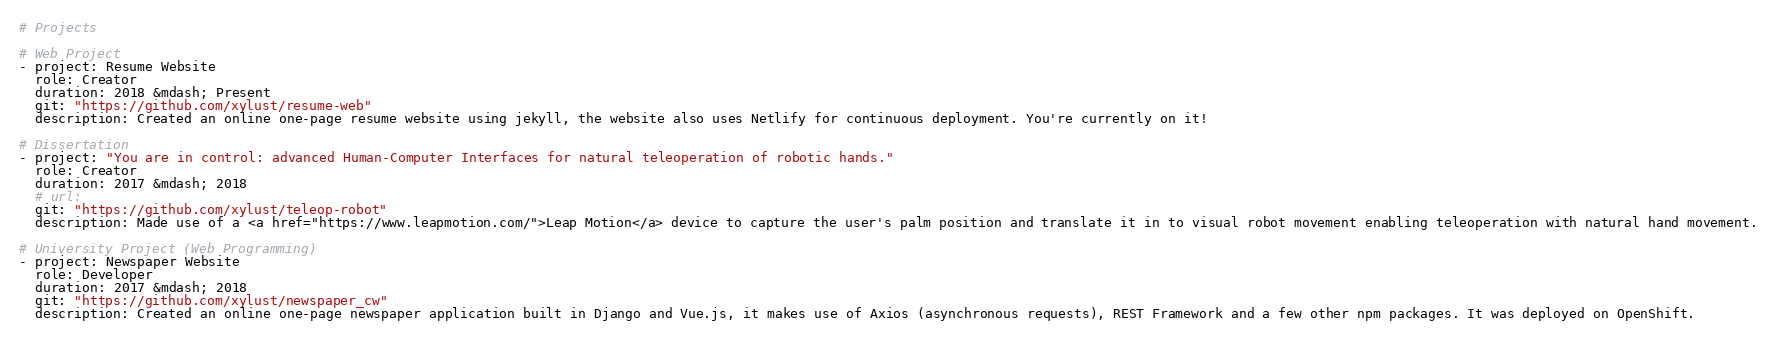<code> <loc_0><loc_0><loc_500><loc_500><_YAML_># Projects

# Web Project
- project: Resume Website
  role: Creator
  duration: 2018 &mdash; Present
  git: "https://github.com/xylust/resume-web"
  description: Created an online one-page resume website using jekyll, the website also uses Netlify for continuous deployment. You're currently on it!

# Dissertation
- project: "You are in control: advanced Human-Computer Interfaces for natural teleoperation of robotic hands."
  role: Creator
  duration: 2017 &mdash; 2018
  # url: 
  git: "https://github.com/xylust/teleop-robot"
  description: Made use of a <a href="https://www.leapmotion.com/">Leap Motion</a> device to capture the user's palm position and translate it in to visual robot movement enabling teleoperation with natural hand movement.

# University Project (Web Programming)
- project: Newspaper Website
  role: Developer
  duration: 2017 &mdash; 2018
  git: "https://github.com/xylust/newspaper_cw"
  description: Created an online one-page newspaper application built in Django and Vue.js, it makes use of Axios (asynchronous requests), REST Framework and a few other npm packages. It was deployed on OpenShift.</code> 